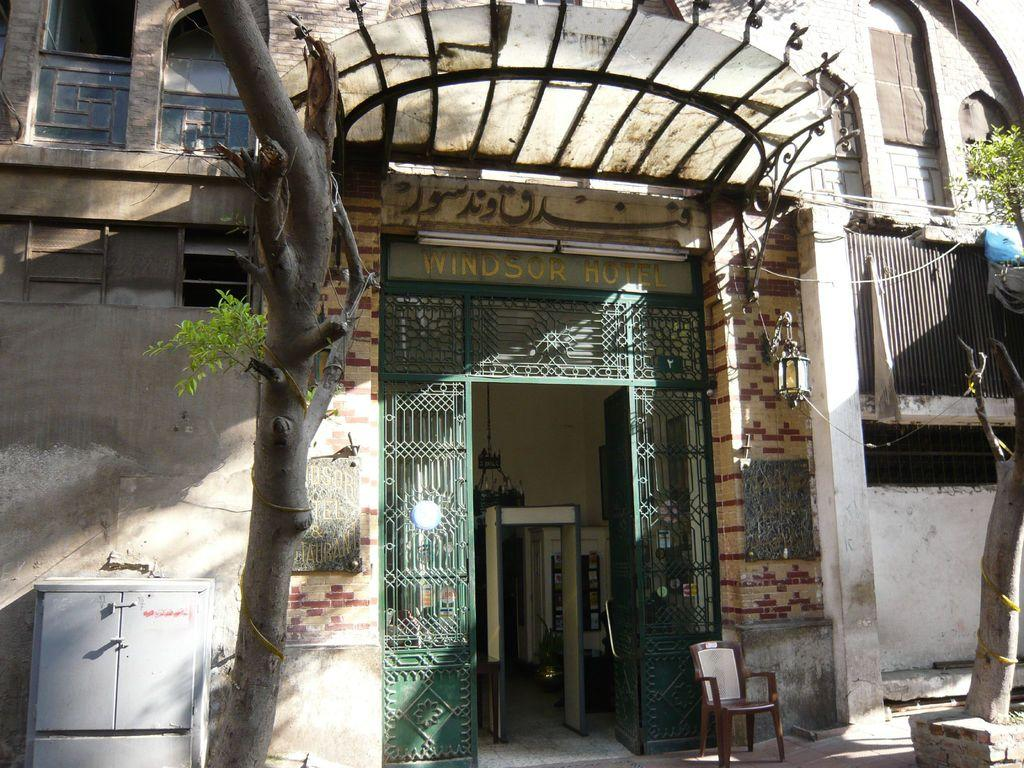<image>
Provide a brief description of the given image. An exterior view of the Windsor Hotel and the entry way. 